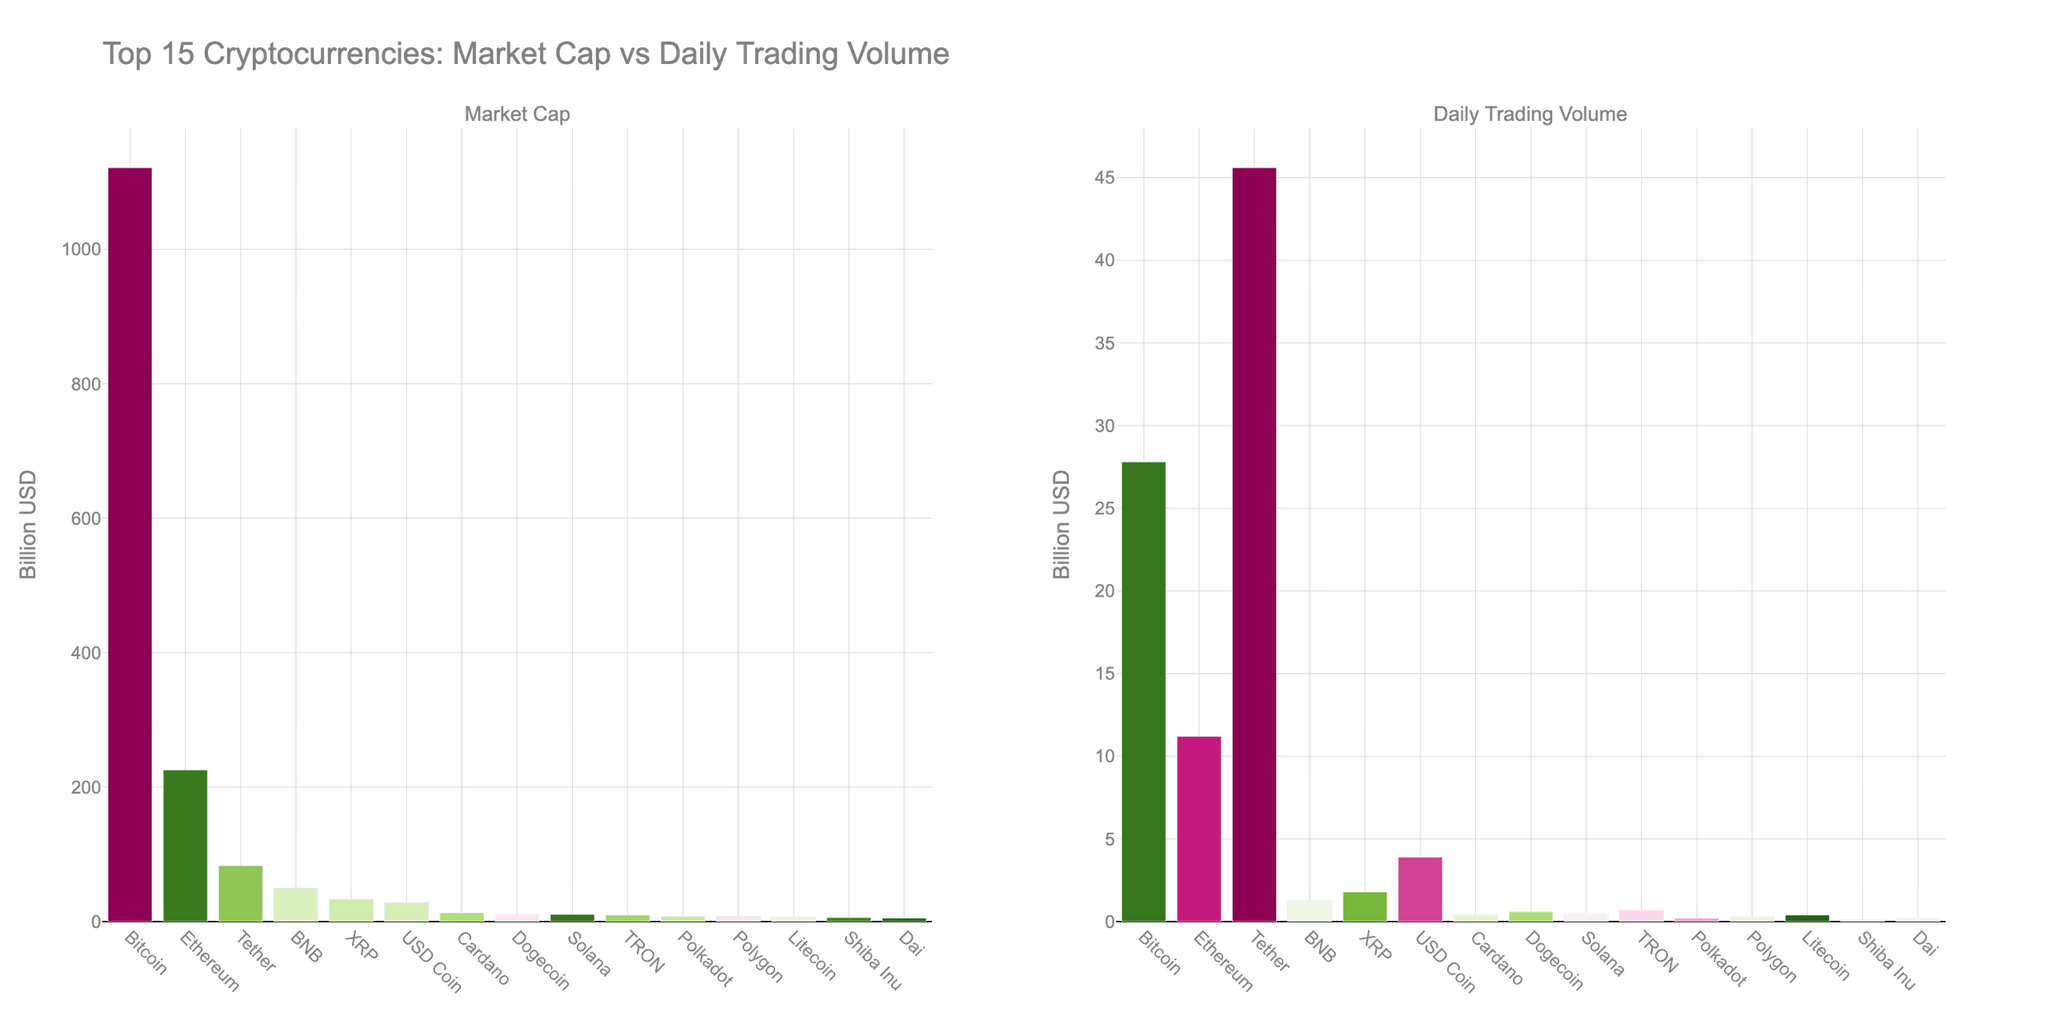Which cryptocurrency has the highest daily trading volume? By looking at the bar chart on the right side, identify the tallest bar which represents the cryptocurrency with the highest daily trading volume. Tether has the tallest bar.
Answer: Tether Which cryptocurrency has a higher market cap, Ethereum or Bitcoin? Compare the heights of the bars for Ethereum and Bitcoin in the Market Cap subplot. Bitcoin's bar is higher than Ethereum's.
Answer: Bitcoin What is the combined market cap of Cardano, Dogecoin, and Solana? Add the market caps of Cardano (13.1 billion USD), Dogecoin (11.2 billion USD), and Solana (10.8 billion USD). 13.1 + 11.2 + 10.8 = 35.1 billion USD.
Answer: 35.1 billion USD Which cryptocurrency has a greater difference between market cap and daily trading volume, BNB or XRP? Calculate the difference between market cap and daily trading volume for BNB (49.7 - 1.3) and XRP (33.2 - 1.8). BNB's difference is 48.4, and XRP's difference is 31.4.
Answer: BNB Which two cryptocurrencies have the closest market caps? Compare the heights of the bars in the Market Cap subplot to find the two bars that are closest in height. Polkadot (8.1 billion USD) and Polygon (7.9 billion USD) are very close.
Answer: Polkadot and Polygon Rank the top three cryptocurrencies by daily trading volume. Order the cryptocurrencies by the heights of the bars in the Daily Trading Volume subplot. The highest bars correspond to Tether, Bitcoin, and Ethereum, respectively.
Answer: Tether, Bitcoin, Ethereum What is the average daily trading volume of Bitcoin, Ethereum, and Tether? Add the daily trading volumes of Bitcoin (27.8 billion USD), Ethereum (11.2 billion USD), and Tether (45.6 billion USD), then divide by 3. (27.8 + 11.2 + 45.6) / 3 = 28.2 billion USD.
Answer: 28.2 billion USD Which cryptocurrency has the smallest market cap? Identify the shortest bar in the Market Cap subplot. Dai has the shortest bar.
Answer: Dai Compare the daily trading volume of USD Coin and XRP. Which one is higher? Look at the heights of the bars for USD Coin and XRP in the Daily Trading Volume subplot. USD Coin's bar is higher than XRP's.
Answer: USD Coin How does the market cap of Litecoin compare to that of Shiba Inu? Compare the heights of the bars for Litecoin and Shiba Inu in the Market Cap subplot. Litecoin's bar is higher than Shiba Inu's.
Answer: Litecoin 